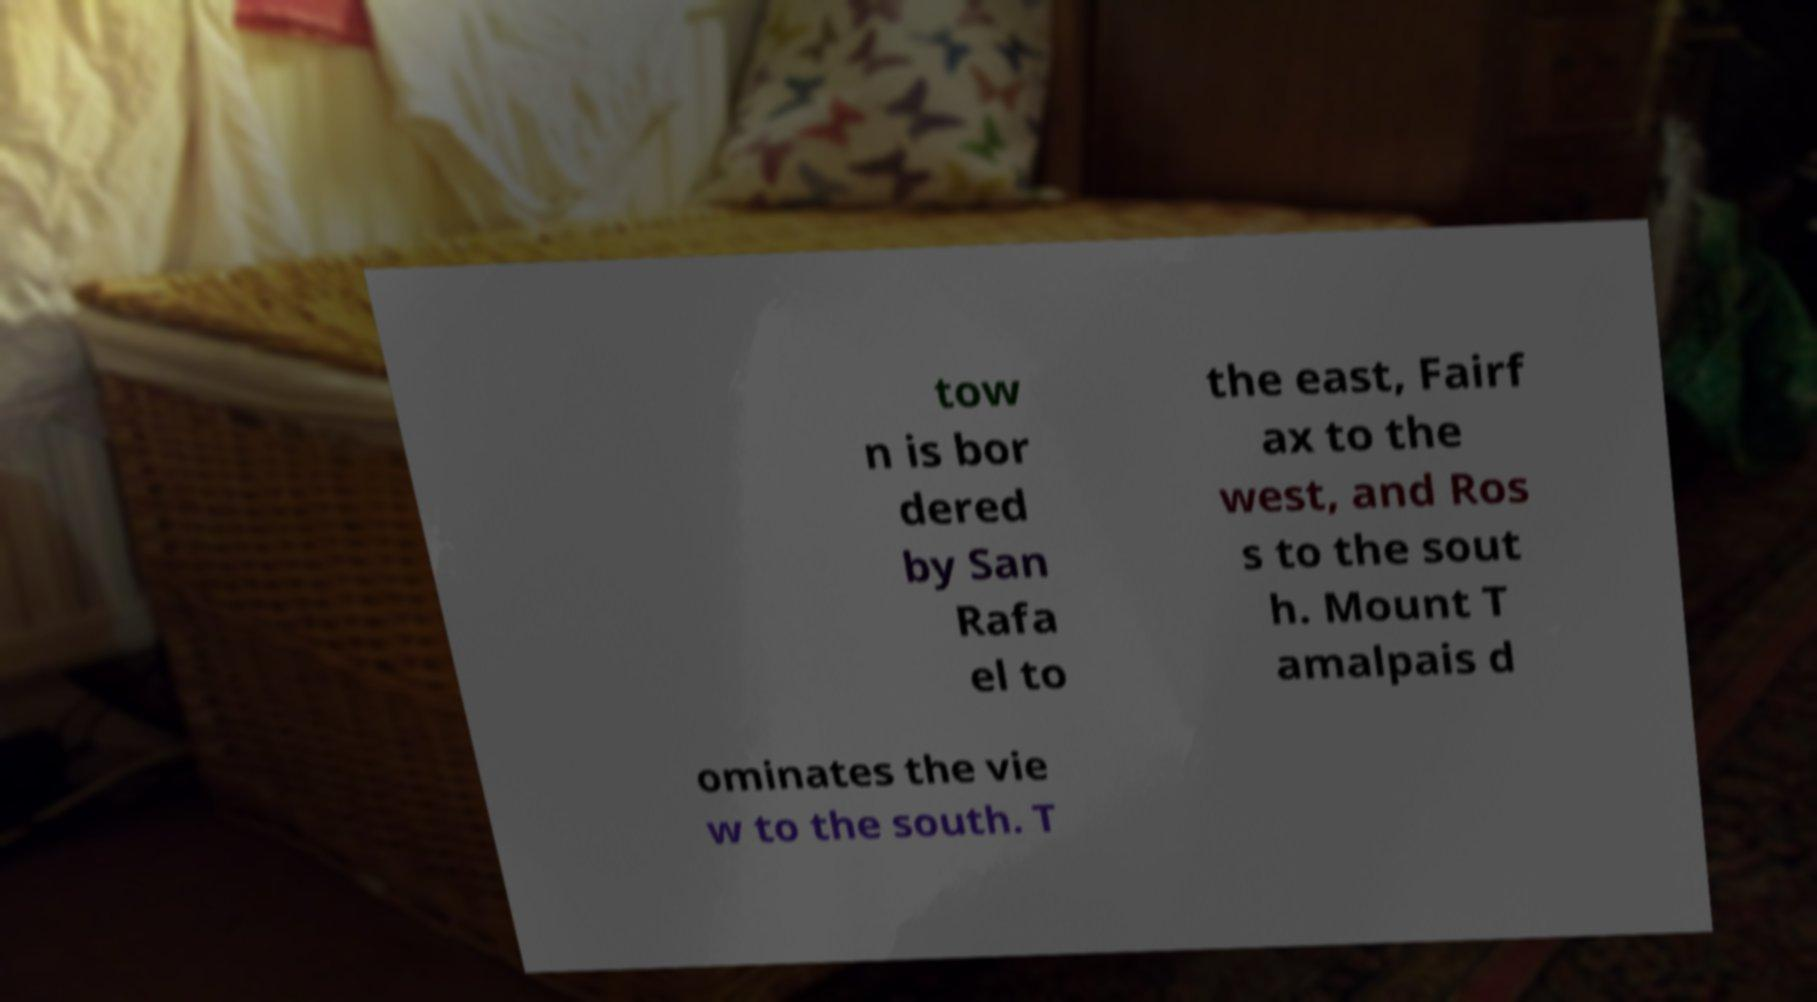I need the written content from this picture converted into text. Can you do that? tow n is bor dered by San Rafa el to the east, Fairf ax to the west, and Ros s to the sout h. Mount T amalpais d ominates the vie w to the south. T 